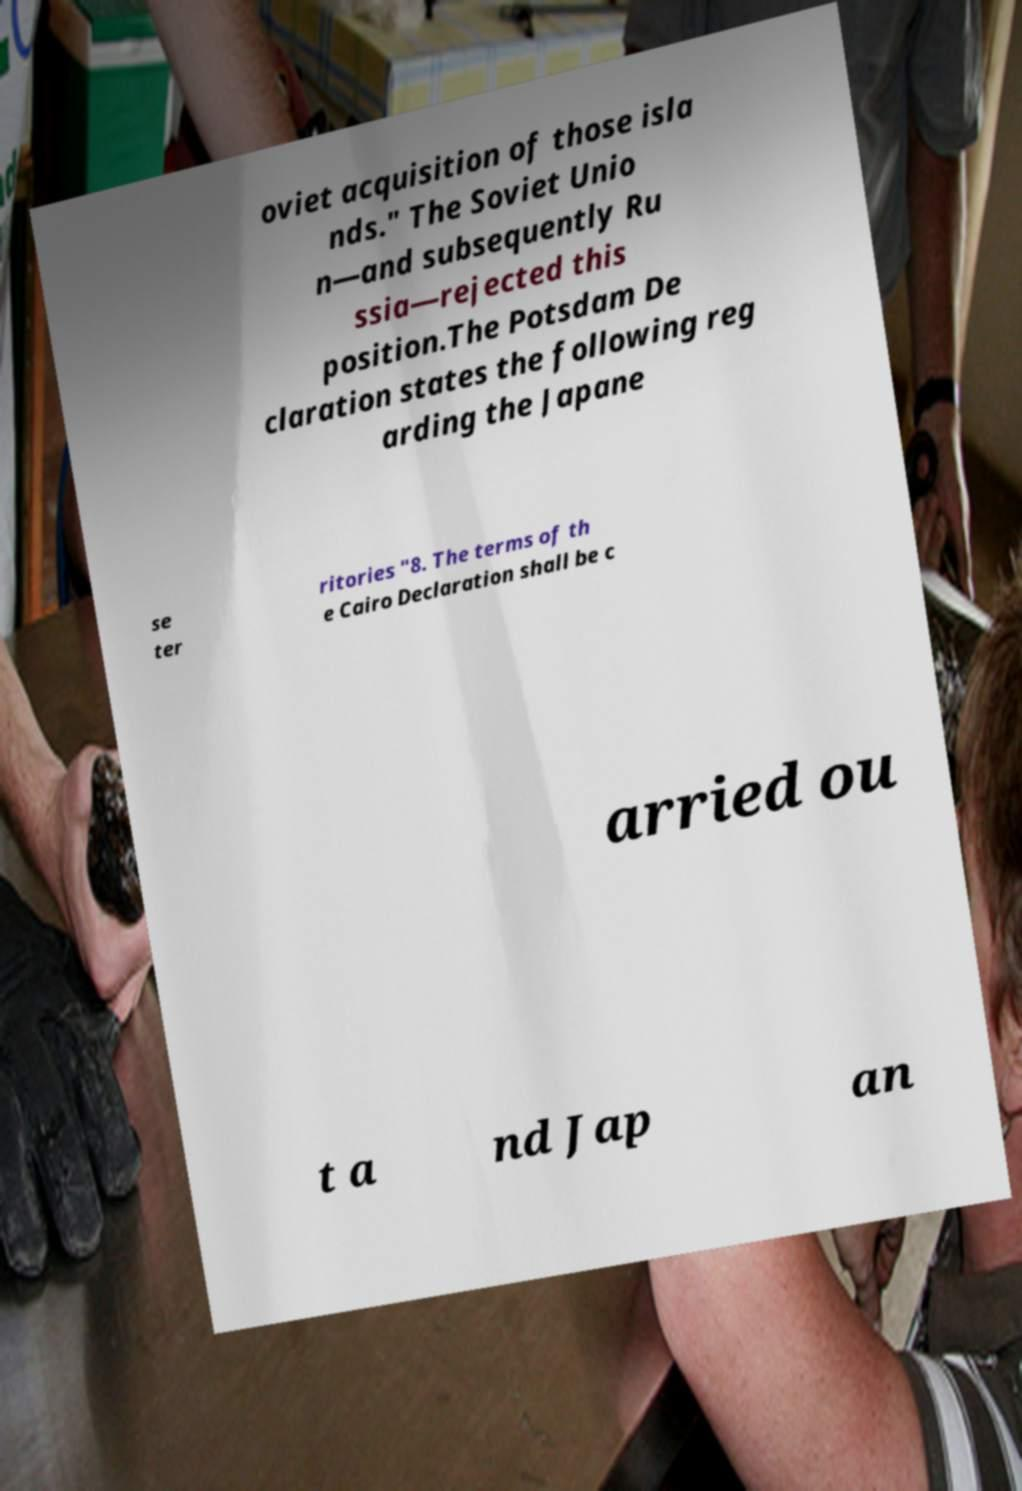Can you accurately transcribe the text from the provided image for me? oviet acquisition of those isla nds." The Soviet Unio n—and subsequently Ru ssia—rejected this position.The Potsdam De claration states the following reg arding the Japane se ter ritories "8. The terms of th e Cairo Declaration shall be c arried ou t a nd Jap an 